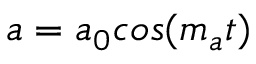<formula> <loc_0><loc_0><loc_500><loc_500>a = a _ { 0 } \cos ( m _ { a } t )</formula> 